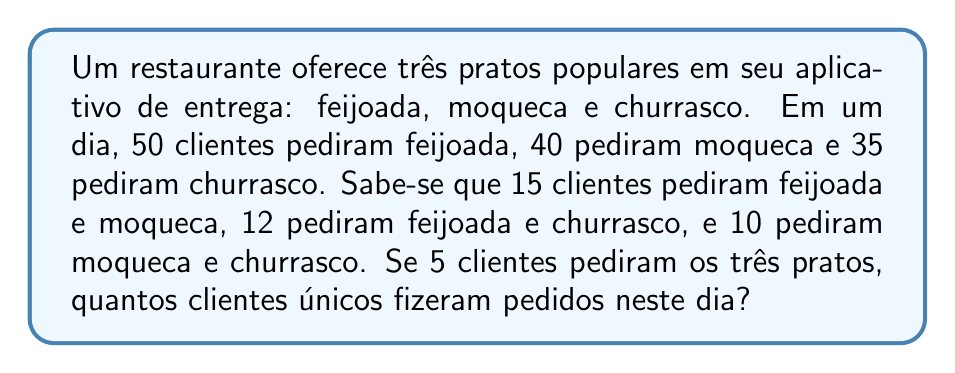Help me with this question. Para resolver este problema, vamos usar o princípio da inclusão-exclusão da teoria dos conjuntos. Definimos:

$F$: conjunto de clientes que pediram feijoada
$M$: conjunto de clientes que pediram moqueca
$C$: conjunto de clientes que pediram churrasco

Temos:
$|F| = 50$, $|M| = 40$, $|C| = 35$
$|F \cap M| = 15$, $|F \cap C| = 12$, $|M \cap C| = 10$
$|F \cap M \cap C| = 5$

A fórmula de inclusão-exclusão para três conjuntos é:

$$|F \cup M \cup C| = |F| + |M| + |C| - |F \cap M| - |F \cap C| - |M \cap C| + |F \cap M \cap C|$$

Substituindo os valores:

$$|F \cup M \cup C| = 50 + 40 + 35 - 15 - 12 - 10 + 5$$

$$|F \cup M \cup C| = 125 - 37 + 5 = 93$$

Portanto, o número total de clientes únicos que fizeram pedidos neste dia é 93.
Answer: 93 clientes únicos 